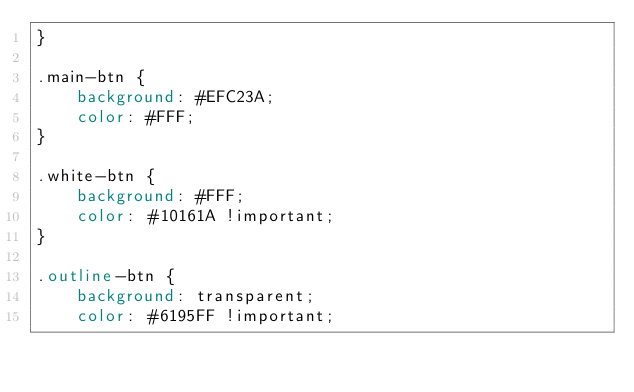<code> <loc_0><loc_0><loc_500><loc_500><_CSS_>}

.main-btn {
    background: #EFC23A;
    color: #FFF;
}

.white-btn {
    background: #FFF;
    color: #10161A !important;
}

.outline-btn {
    background: transparent;
    color: #6195FF !important;</code> 